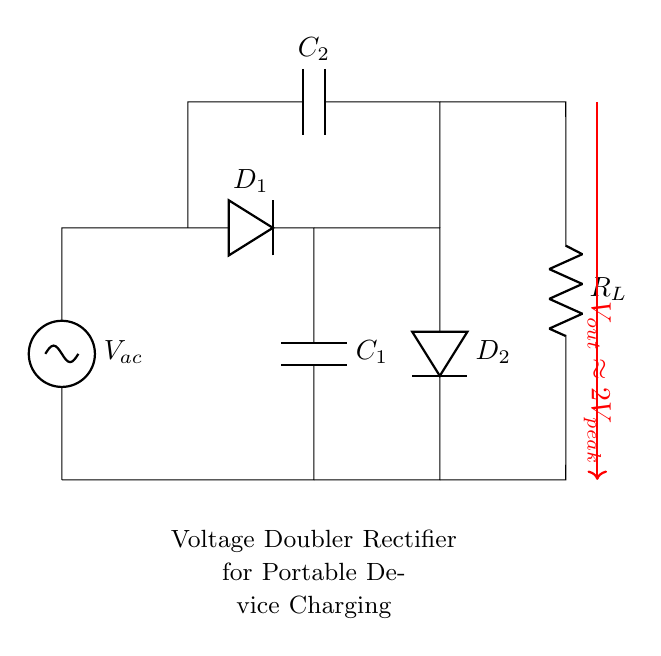What is the main function of this circuit? The main function is to charge batteries, specifically to double the input AC voltage to provide a higher DC output suitable for charging.
Answer: Charge batteries What type of diodes are used in this circuit? The circuit includes two diodes, labeled D1 and D2, which rectify the AC input into DC output.
Answer: Two diodes What is the approximate output voltage of the circuit? The output voltage is approximately double the peak voltage of the AC input, indicated by the label near the output arrow, showing it as two times the peak voltage.
Answer: Two times the peak voltage What components are used to store charge in the circuit? The circuit uses two capacitors, labeled C1 and C2, to store energy before delivering it to the load.
Answer: Two capacitors What is the role of the resistor in the circuit? The resistor, labeled RL, represents the load that the circuit is powering, illustrating how the output voltage is used in practical applications.
Answer: The load How do the capacitors contribute to the function of the circuit? The capacitors charge during the positive cycles of the AC input and provide a smoother DC output by discharging during negative cycles, thus ensuring a stable output voltage.
Answer: Smooth the DC output 